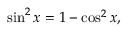Convert formula to latex. <formula><loc_0><loc_0><loc_500><loc_500>\sin ^ { 2 } x = 1 - \cos ^ { 2 } x ,</formula> 